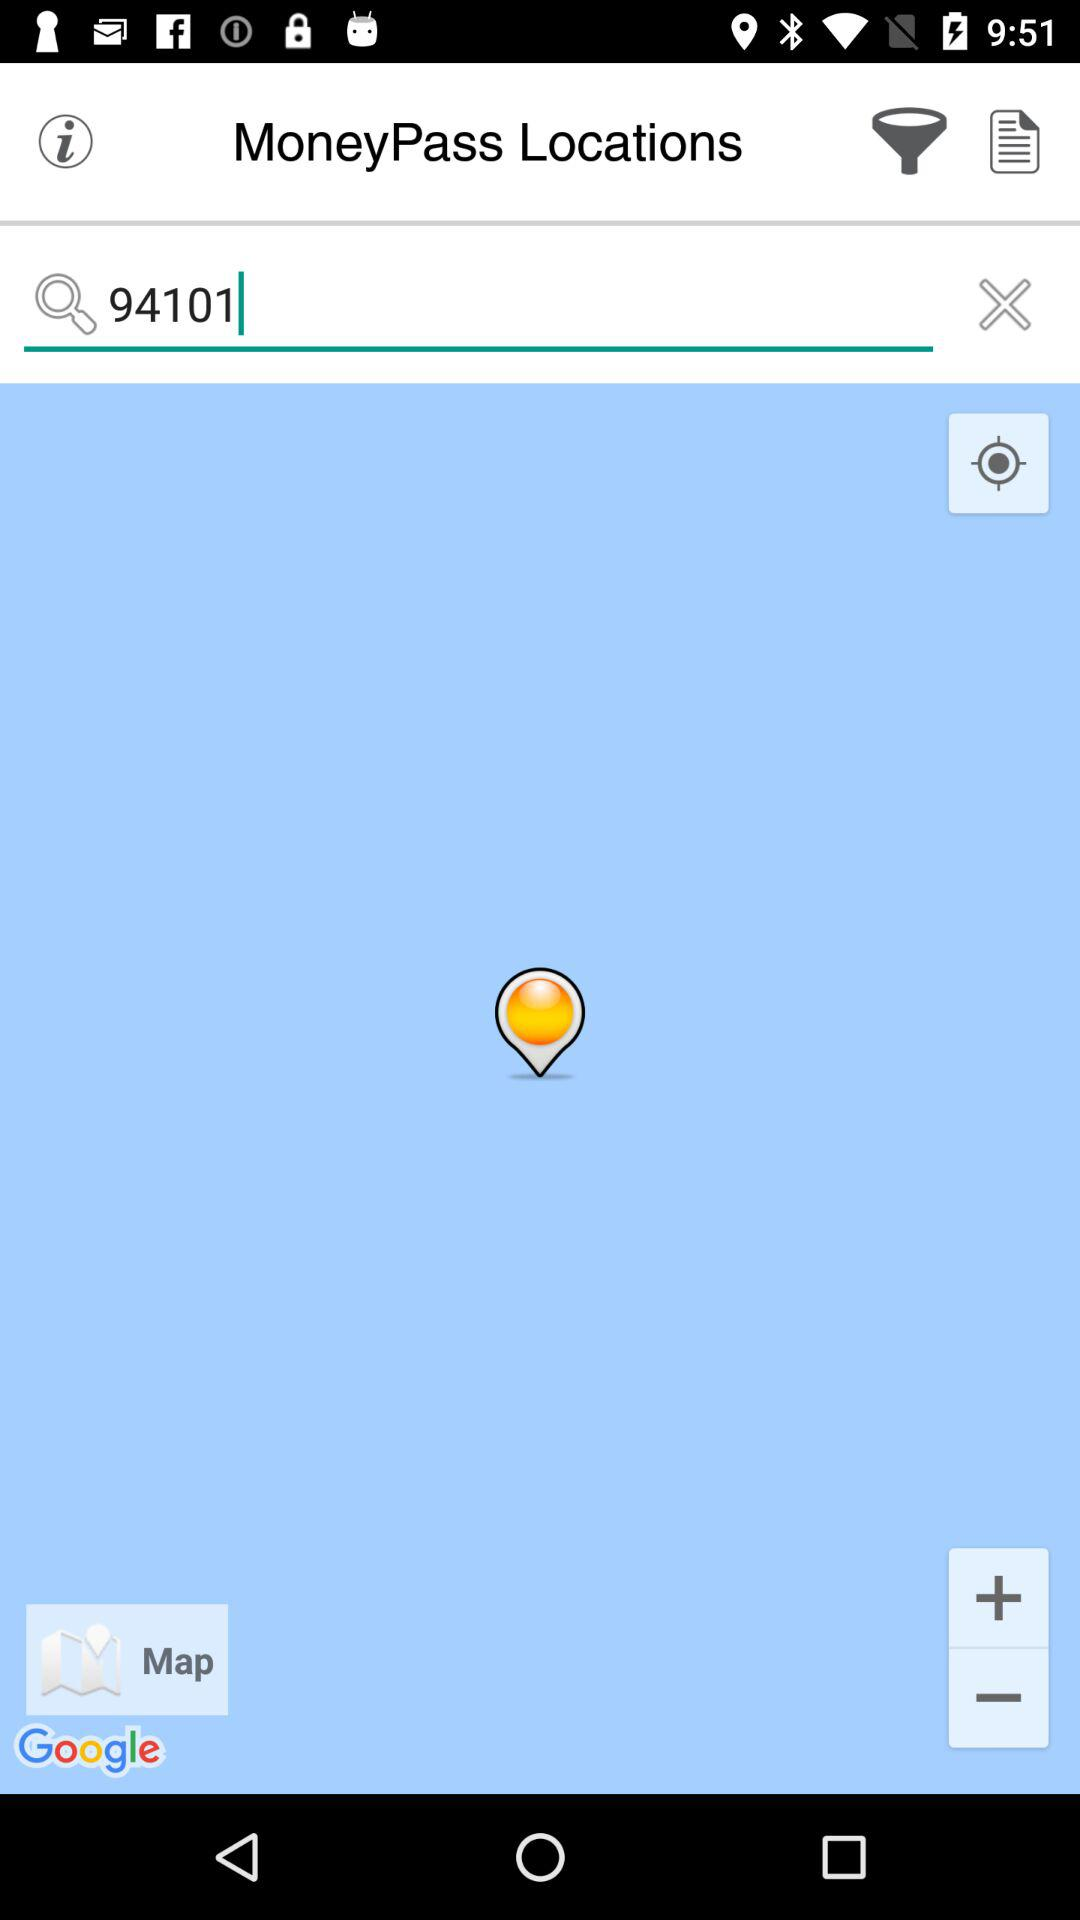What is the name of the application? The name of the application is "MoneyPass". 